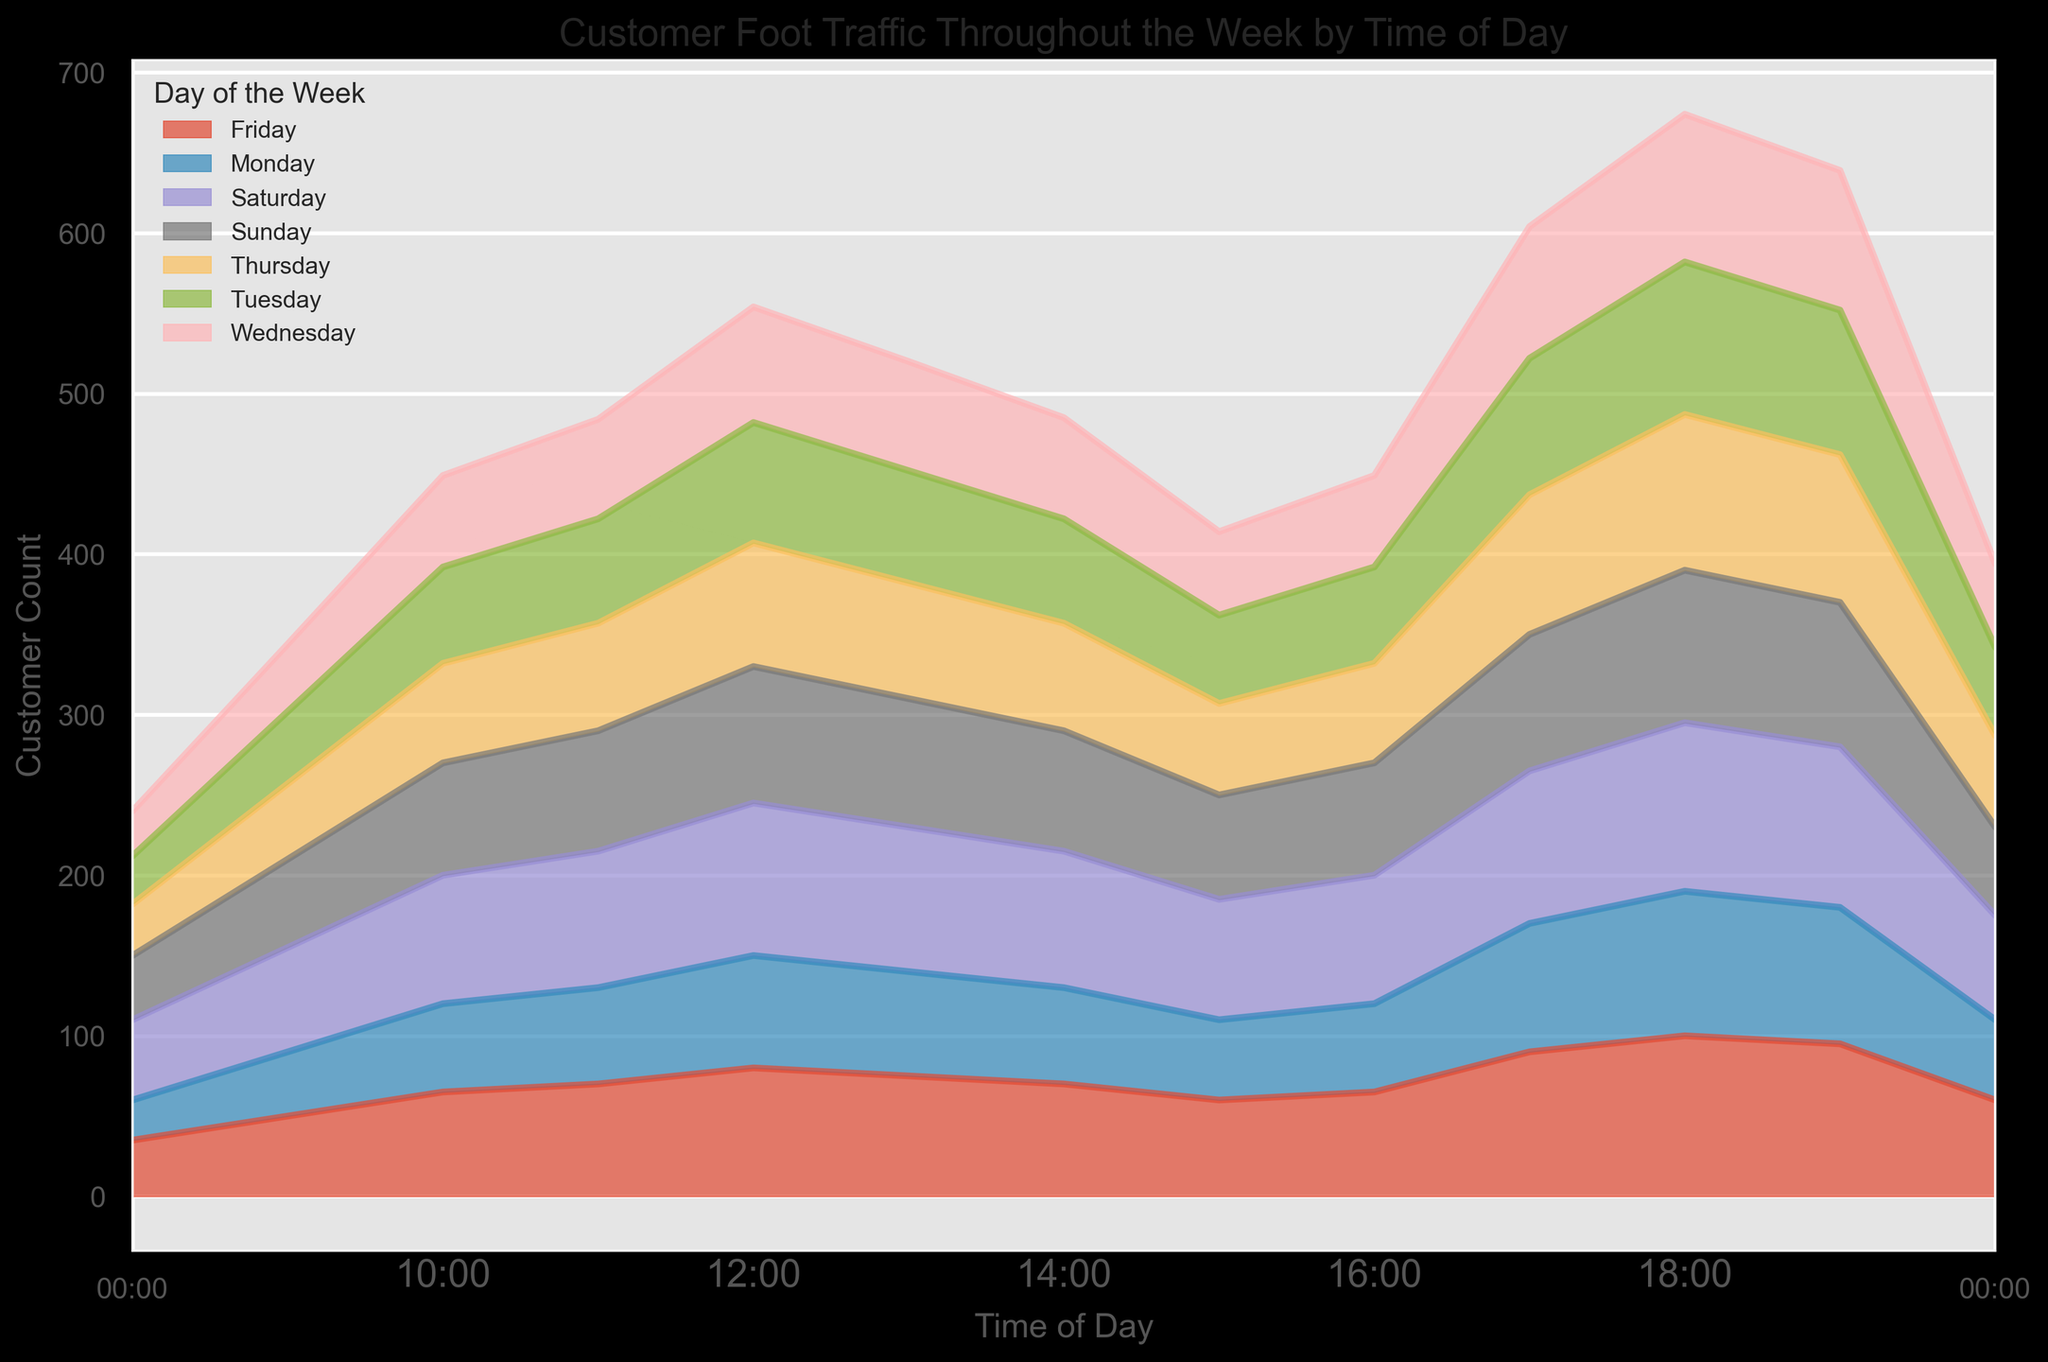What is the busiest time of day on Saturday? On the area chart, look for the day labeled "Saturday" and identify the peak point. The highest customer count occurs around 18:00, where the value reaches 105.
Answer: 18:00 Which day has the lowest customer foot traffic at 08:00? At 08:00, compare the heights of the area segments for each day of the week. Monday has the lowest customer count of 25.
Answer: Monday How does the customer count at 12:00 on Friday compare to Sunday? Find the customer counts at 12:00 for both Friday and Sunday on the area chart. Friday has 80 customers, and Sunday has 85 customers. Therefore, Sunday has a higher count.
Answer: Sunday What is the total customer count for Saturday from 17:00 to 19:00? Sum the customer counts for Saturday at 17:00, 18:00, and 19:00: 95 + 105 + 100. This equals 300.
Answer: 300 Is there any day where the customer count at 15:00 is greater than at 14:00? Compare customer counts at 14:00 and 15:00 for each day of the week. On no day is the count at 15:00 greater than at 14:00.
Answer: No Compare the morning traffic (08:00 - 12:00) and evening traffic (17:00 - 20:00) on Monday. Which period is busier? Calculate the total customer count for Monday from 08:00 to 12:00: 25 + 40 + 55 + 60 + 70 = 250. Then, calculate for 17:00 to 20:00: 80 + 90 + 85 + 50 = 305. Thus, the evening period is busier.
Answer: Evening What is the average customer count at 11:00 across all days? Add customer counts at 11:00 for each day and divide by 7: (60 + 65 + 62 + 67 + 70 + 85 + 75)/7 = 484/7 = 69.14 (approx).
Answer: ~69 Which day experiences the least evening peak traffic (17:00 - 20:00)? Sum up the customer counts from 17:00 to 20:00 for each day. Identify the day with the lowest total: Monday = 305, Tuesday = 325, Wednesday = 313, Thursday = 333, Friday = 345, Saturday = 365, Sunday = 325. Monday has the least evening peak traffic.
Answer: Monday 